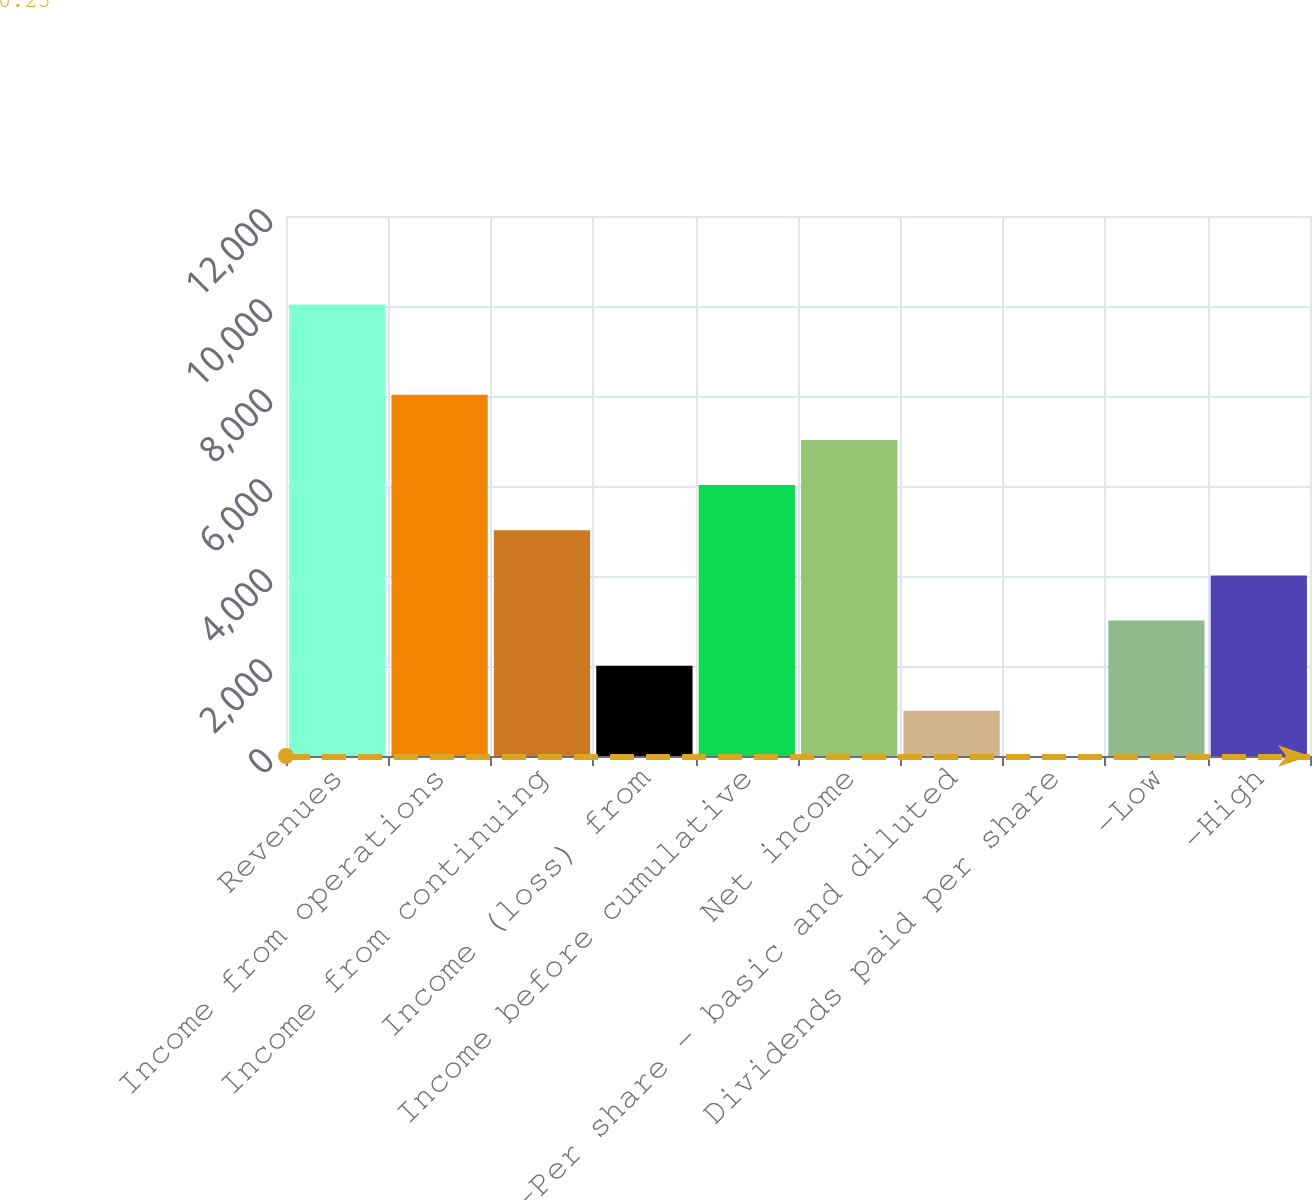Convert chart to OTSL. <chart><loc_0><loc_0><loc_500><loc_500><bar_chart><fcel>Revenues<fcel>Income from operations<fcel>Income from continuing<fcel>Income (loss) from<fcel>Income before cumulative<fcel>Net income<fcel>-Per share - basic and diluted<fcel>Dividends paid per share<fcel>-Low<fcel>-High<nl><fcel>10033<fcel>8026.47<fcel>5016.63<fcel>2006.79<fcel>6019.91<fcel>7023.19<fcel>1003.51<fcel>0.23<fcel>3010.07<fcel>4013.35<nl></chart> 